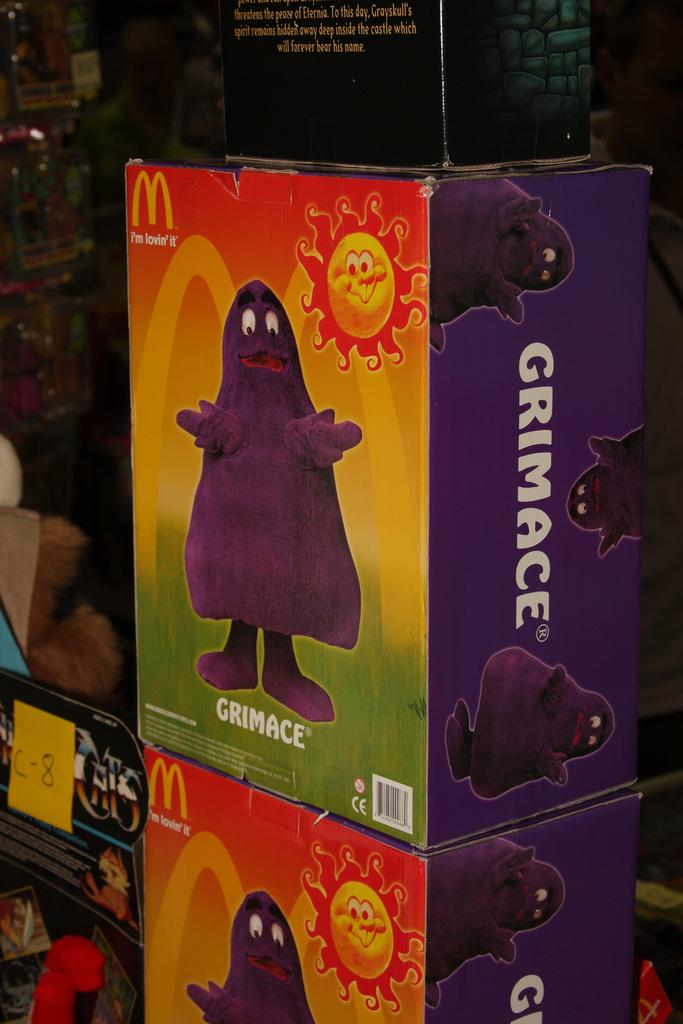<image>
Present a compact description of the photo's key features. A box for a Grimace stuffed toy from McDonald's. 